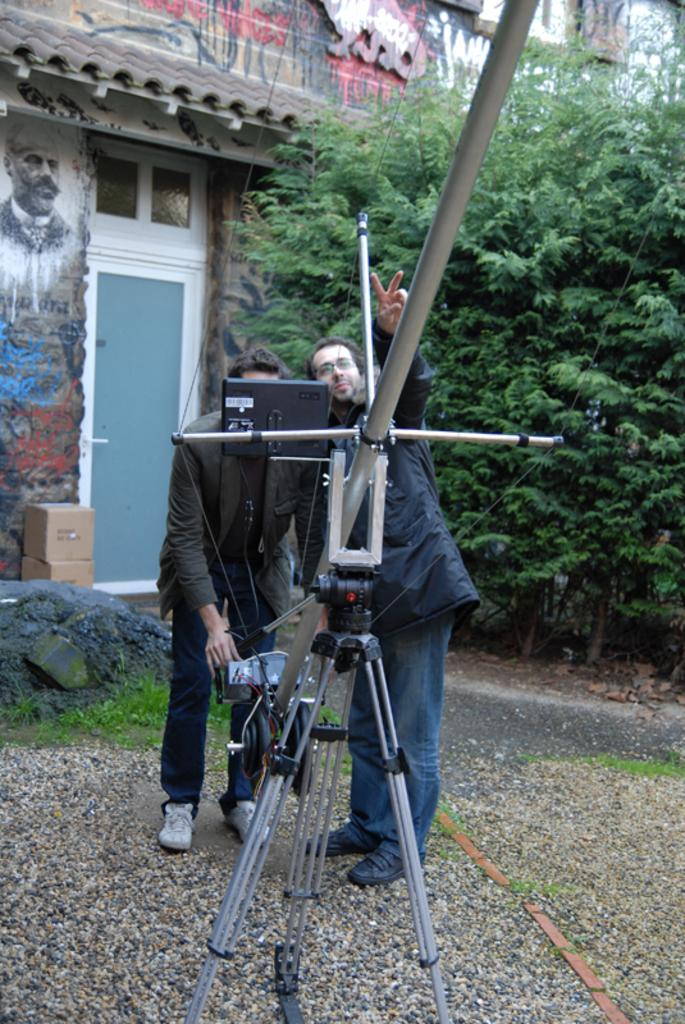How many people are in the image? There are two persons standing on the ground. What is in front of the persons? There is a stand in front of the persons. What type of natural environment can be seen in the image? There are trees visible in the image. What type of structure is present in the image? There is a building in the image. What feature of the building is visible in the image? There is a door in the image. What type of coal is being used to shake hands in the image? There is no coal or handshake present in the image. What type of agreement is being made between the two persons in the image? There is no indication of an agreement being made between the two persons in the image. 